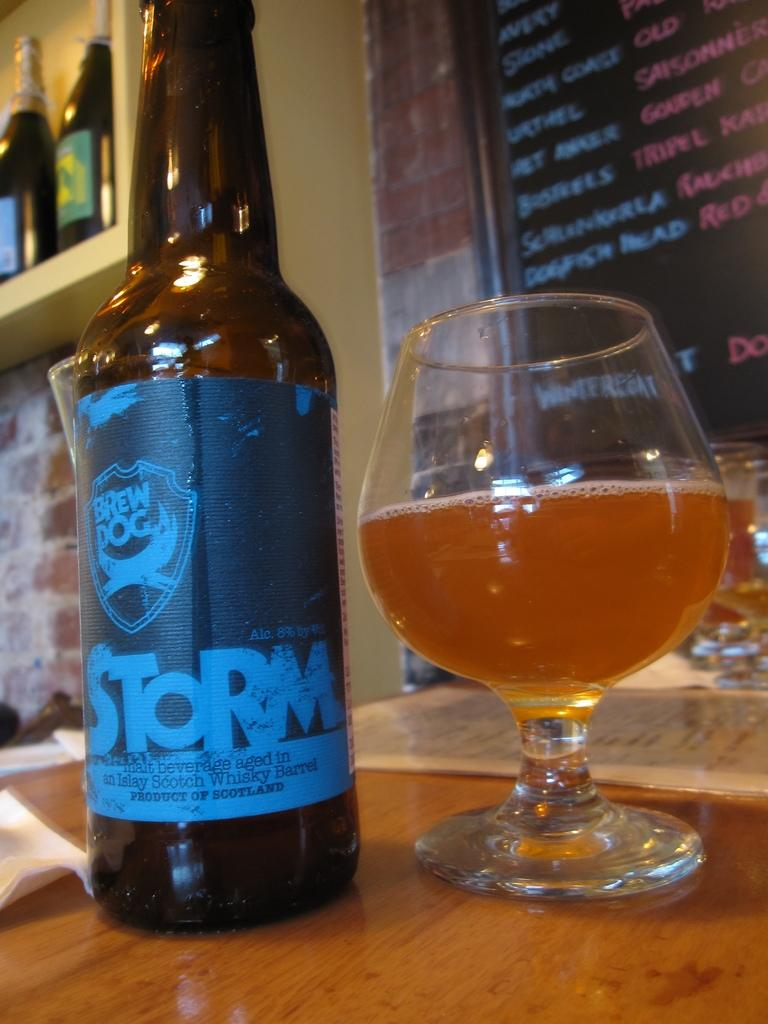<image>
Write a terse but informative summary of the picture. A bottle of a beer with a label that says STORM and a glass of beer placed side by side. 